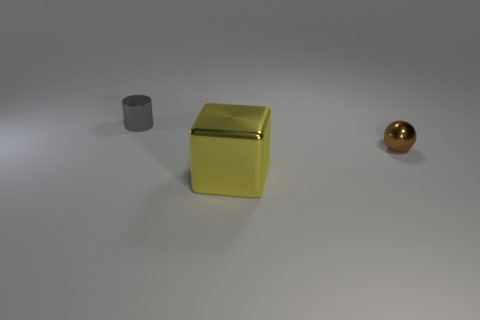Does the small object that is in front of the small gray cylinder have the same material as the tiny thing that is behind the small brown ball?
Provide a succinct answer. Yes. Is there anything else that has the same shape as the brown object?
Keep it short and to the point. No. Is the tiny brown thing made of the same material as the thing that is in front of the small ball?
Offer a terse response. Yes. There is a tiny metallic thing on the right side of the small shiny object behind the small shiny thing in front of the gray object; what is its color?
Ensure brevity in your answer.  Brown. The object that is the same size as the metal sphere is what shape?
Keep it short and to the point. Cylinder. Is there anything else that has the same size as the sphere?
Offer a very short reply. Yes. There is a thing in front of the small shiny ball; is its size the same as the cylinder that is left of the large object?
Provide a short and direct response. No. There is a object that is in front of the small ball; how big is it?
Offer a very short reply. Large. There is a object that is the same size as the brown ball; what color is it?
Provide a short and direct response. Gray. Do the gray metallic thing and the yellow cube have the same size?
Provide a succinct answer. No. 